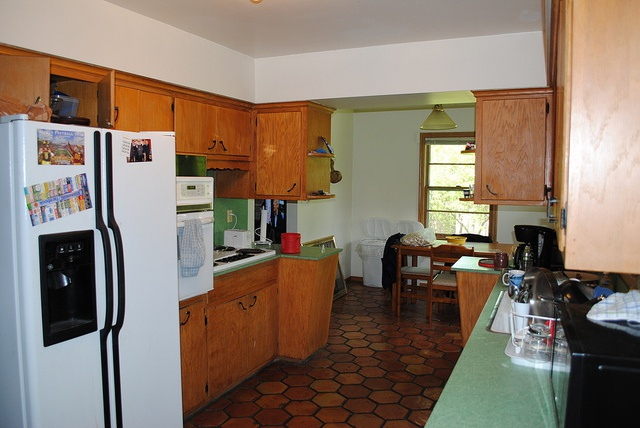Describe the objects in this image and their specific colors. I can see refrigerator in darkgray, lightgray, and black tones, microwave in darkgray, black, gray, and teal tones, microwave in darkgray and lightgray tones, oven in darkgray, black, and gray tones, and chair in darkgray, black, maroon, and gray tones in this image. 